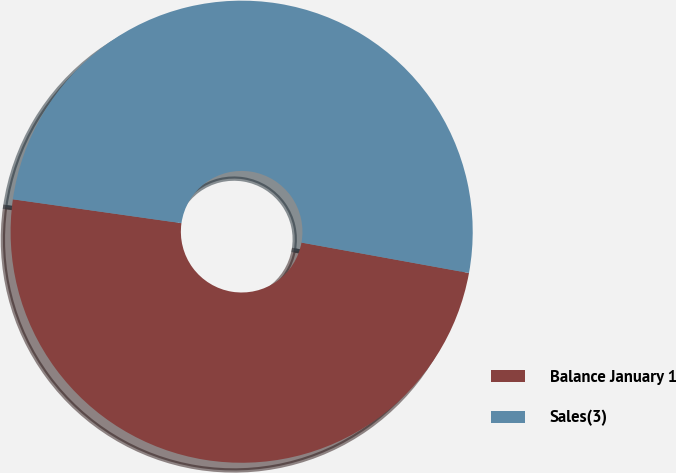Convert chart to OTSL. <chart><loc_0><loc_0><loc_500><loc_500><pie_chart><fcel>Balance January 1<fcel>Sales(3)<nl><fcel>49.38%<fcel>50.62%<nl></chart> 